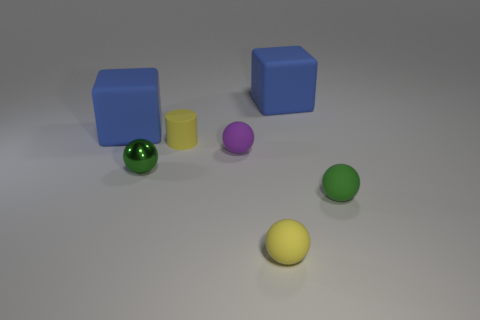Subtract all green balls. How many were subtracted if there are1green balls left? 1 Subtract all tiny yellow spheres. How many spheres are left? 3 Subtract 2 spheres. How many spheres are left? 2 Subtract all purple spheres. How many spheres are left? 3 Subtract all blue spheres. Subtract all green cubes. How many spheres are left? 4 Add 1 small spheres. How many objects exist? 8 Subtract all spheres. How many objects are left? 3 Subtract all small red things. Subtract all large objects. How many objects are left? 5 Add 2 tiny yellow objects. How many tiny yellow objects are left? 4 Add 1 large blue objects. How many large blue objects exist? 3 